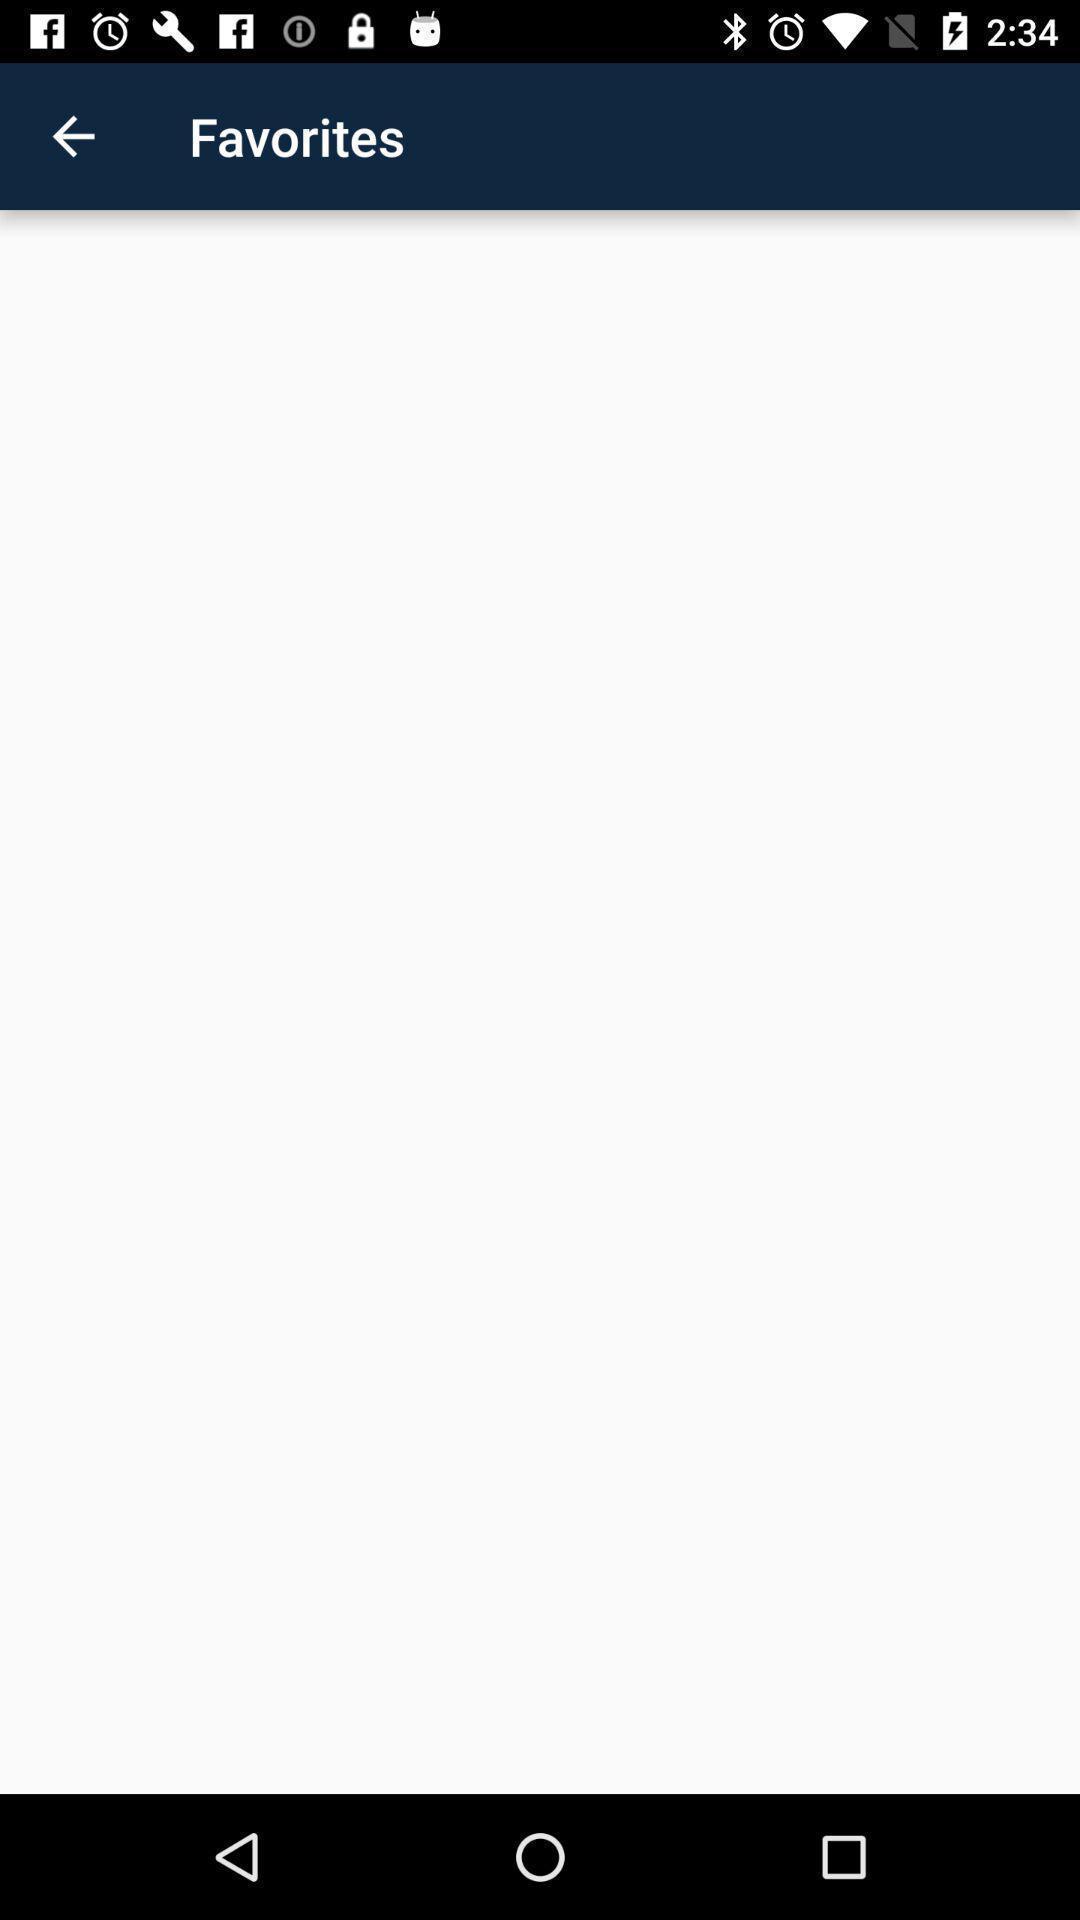Tell me about the visual elements in this screen capture. Page that displaying about favorites. 